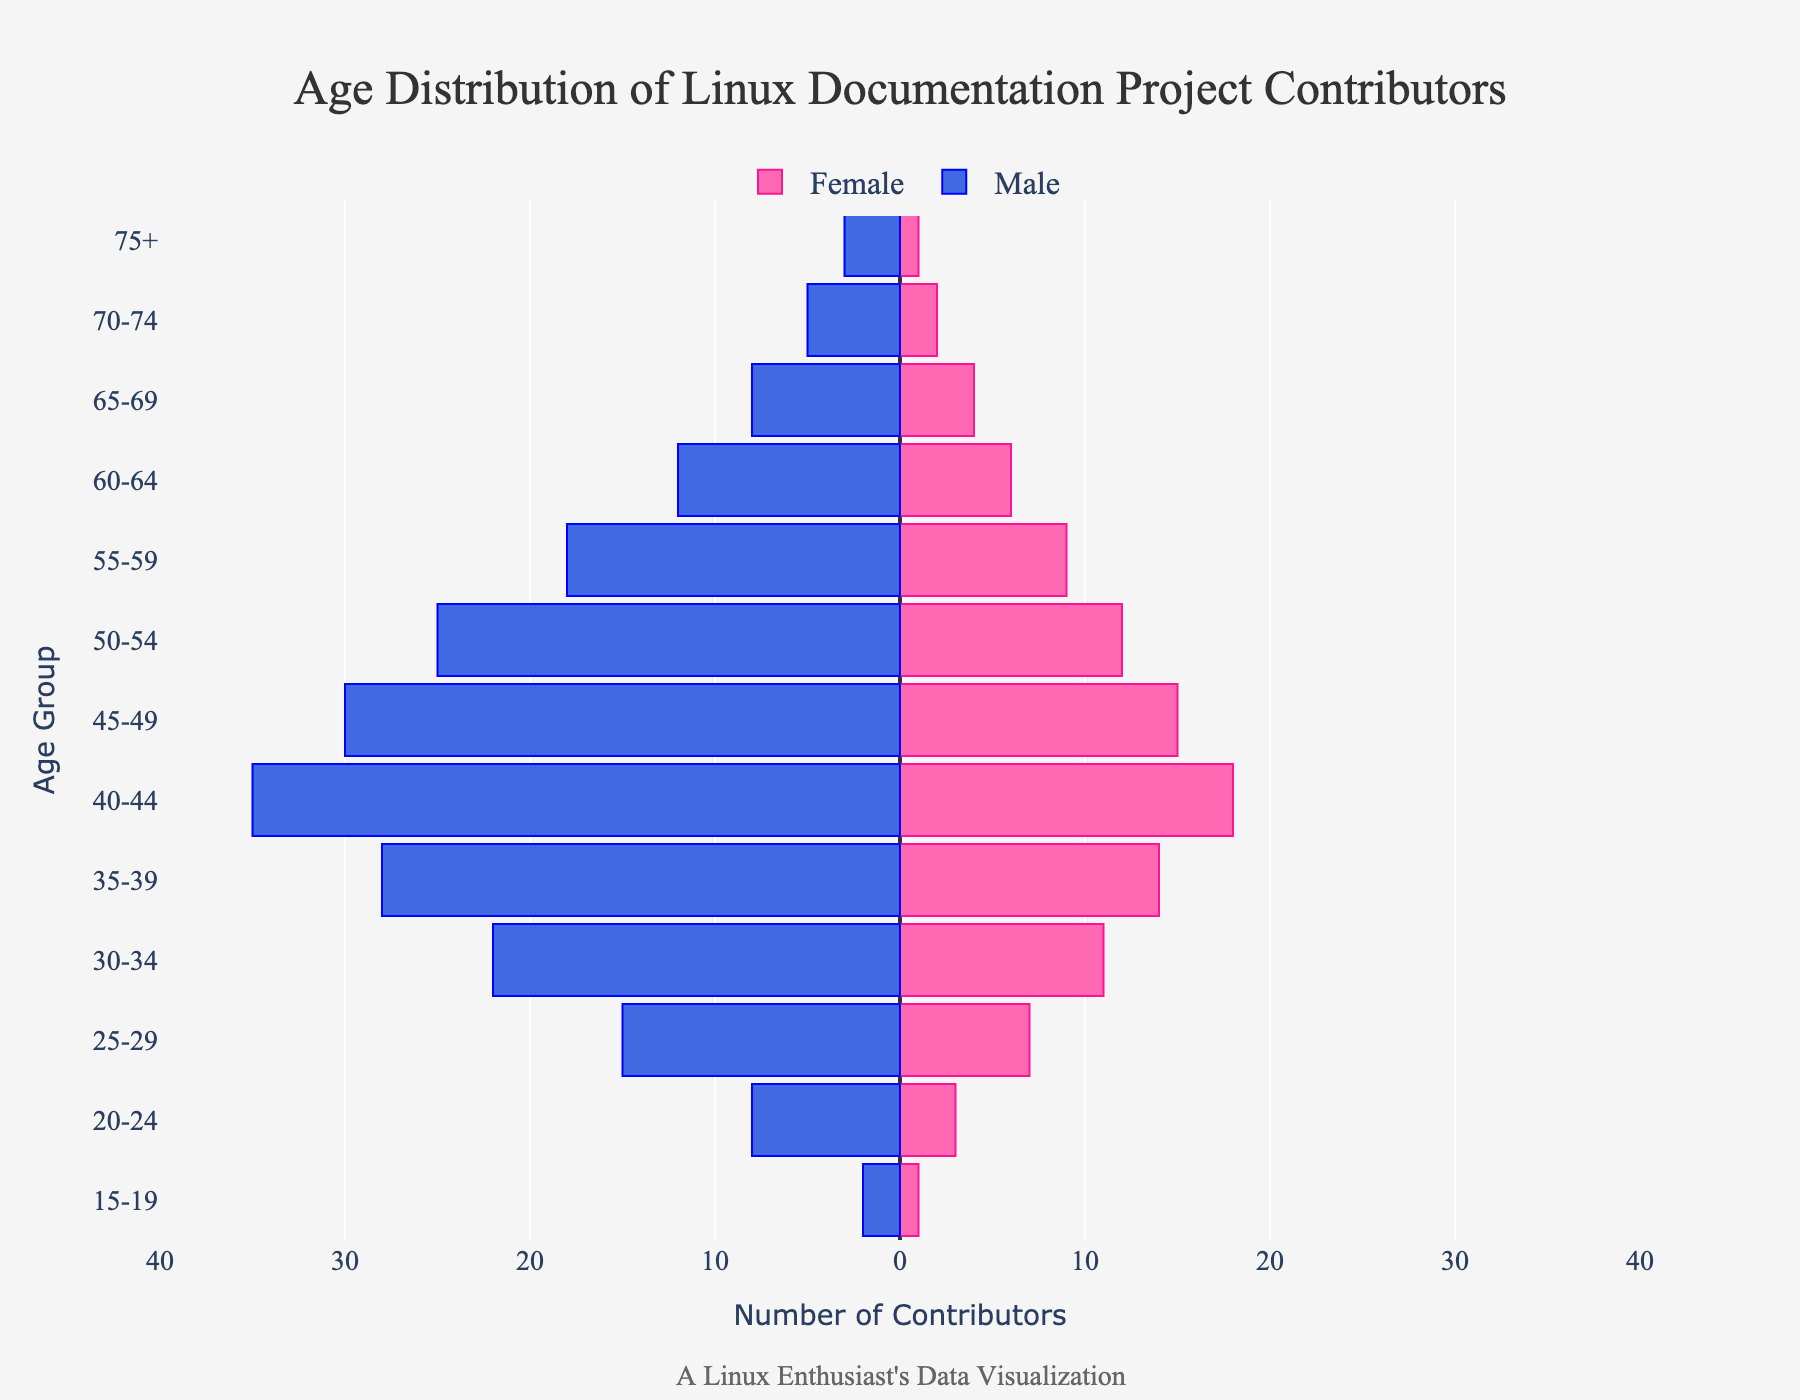How many total contributors are in the age group 40-44? To find the total contributors in the age group 40-44, sum up the male and female contributors in that group. According to the data, there are 35 male contributors and 18 female contributors in this age group. So, the total number is 35 + 18 = 53.
Answer: 53 Which age group has the highest number of male contributors? To determine which age group has the highest number of male contributors, look at the male values in the data. The age group 40-44 has the highest number with 35 male contributors.
Answer: 40-44 What is the difference between male and female contributors in the age group 25-29? To find the difference between male and female contributors in the age group 25-29, subtract the number of female contributors from the number of male contributors. According to the data, there are 15 male contributors and 7 female contributors. So, the difference is 15 - 7 = 8.
Answer: 8 Which age group has more contributors overall: 30-34 or 50-54? To determine which age group has more contributors overall, sum the male and female contributors in each age group and compare the totals. For 30-34, there are 22 males and 11 females, making a total of 22 + 11 = 33. For 50-54, there are 25 males and 12 females, making a total of 25 + 12 = 37. Therefore, the age group 50-54 has more contributors.
Answer: 50-54 What is the average number of female contributors across all age groups? To calculate the average number of female contributors, sum the female values across all age groups and divide by the number of age groups. The sum of female contributors is 1+3+7+11+14+18+15+12+9+6+4+2+1=103. There are 13 age groups. So, the average is 103 / 13 ≈ 7.92.
Answer: ~7.92 Between the age groups 20-24 and 25-29, which has a greater total number of contributors and by how much? First, calculate the total number of contributors for each age group. For 20-24, there are 8 males and 3 females, giving a total of 8 + 3 = 11. For 25-29, there are 15 males and 7 females, giving a total of 15 + 7 = 22. So, the age group 25-29 has more contributors, with a difference of 22 - 11 = 11.
Answer: 25-29, by 11 What is the total number of male contributors across all age groups? Sum the values of male contributors across all age groups. The sum is 2+8+15+22+28+35+30+25+18+12+8+5+3=211. So, the total number of male contributors is 211.
Answer: 211 